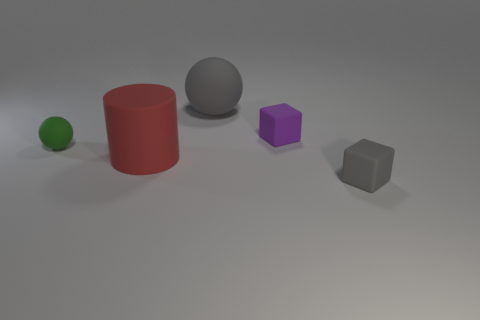Add 5 purple matte cylinders. How many objects exist? 10 Subtract all cylinders. How many objects are left? 4 Subtract all tiny green rubber balls. Subtract all gray rubber things. How many objects are left? 2 Add 1 tiny gray matte objects. How many tiny gray matte objects are left? 2 Add 4 purple metallic cylinders. How many purple metallic cylinders exist? 4 Subtract 1 gray blocks. How many objects are left? 4 